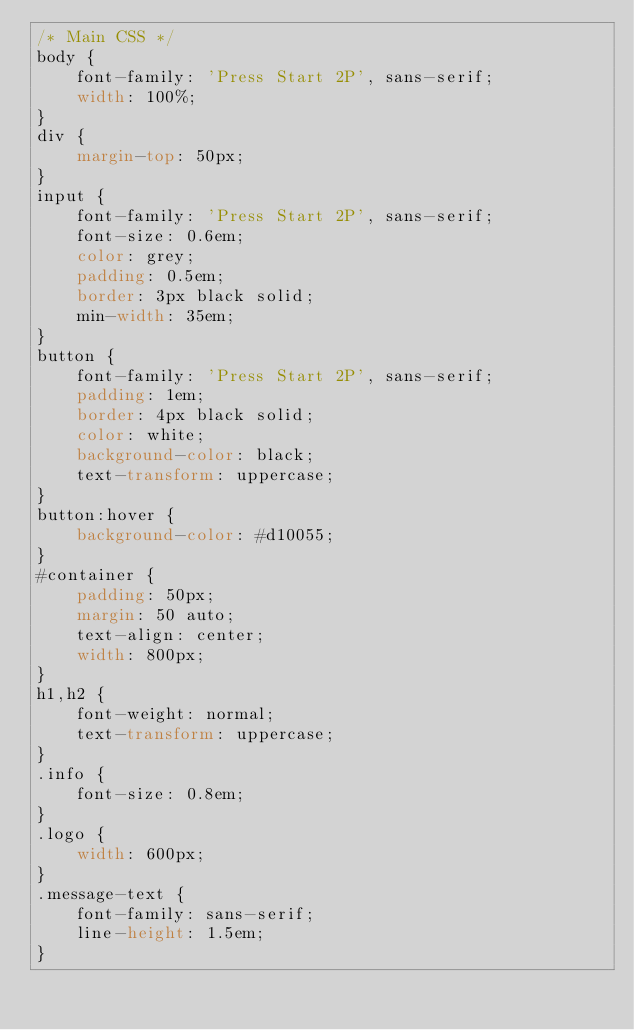<code> <loc_0><loc_0><loc_500><loc_500><_CSS_>/* Main CSS */
body {
    font-family: 'Press Start 2P', sans-serif;
    width: 100%;
}
div {
    margin-top: 50px;
}
input {
    font-family: 'Press Start 2P', sans-serif;
    font-size: 0.6em;
    color: grey;
    padding: 0.5em;
    border: 3px black solid;
    min-width: 35em;
}
button {
    font-family: 'Press Start 2P', sans-serif;
    padding: 1em;
    border: 4px black solid;
    color: white;
    background-color: black;
    text-transform: uppercase;
}
button:hover {
    background-color: #d10055;
}
#container {
    padding: 50px;
    margin: 50 auto;
    text-align: center;
    width: 800px;
}
h1,h2 {
    font-weight: normal;
    text-transform: uppercase;
}
.info {
    font-size: 0.8em;
}
.logo {
    width: 600px;
}
.message-text {
    font-family: sans-serif;
    line-height: 1.5em;
}</code> 